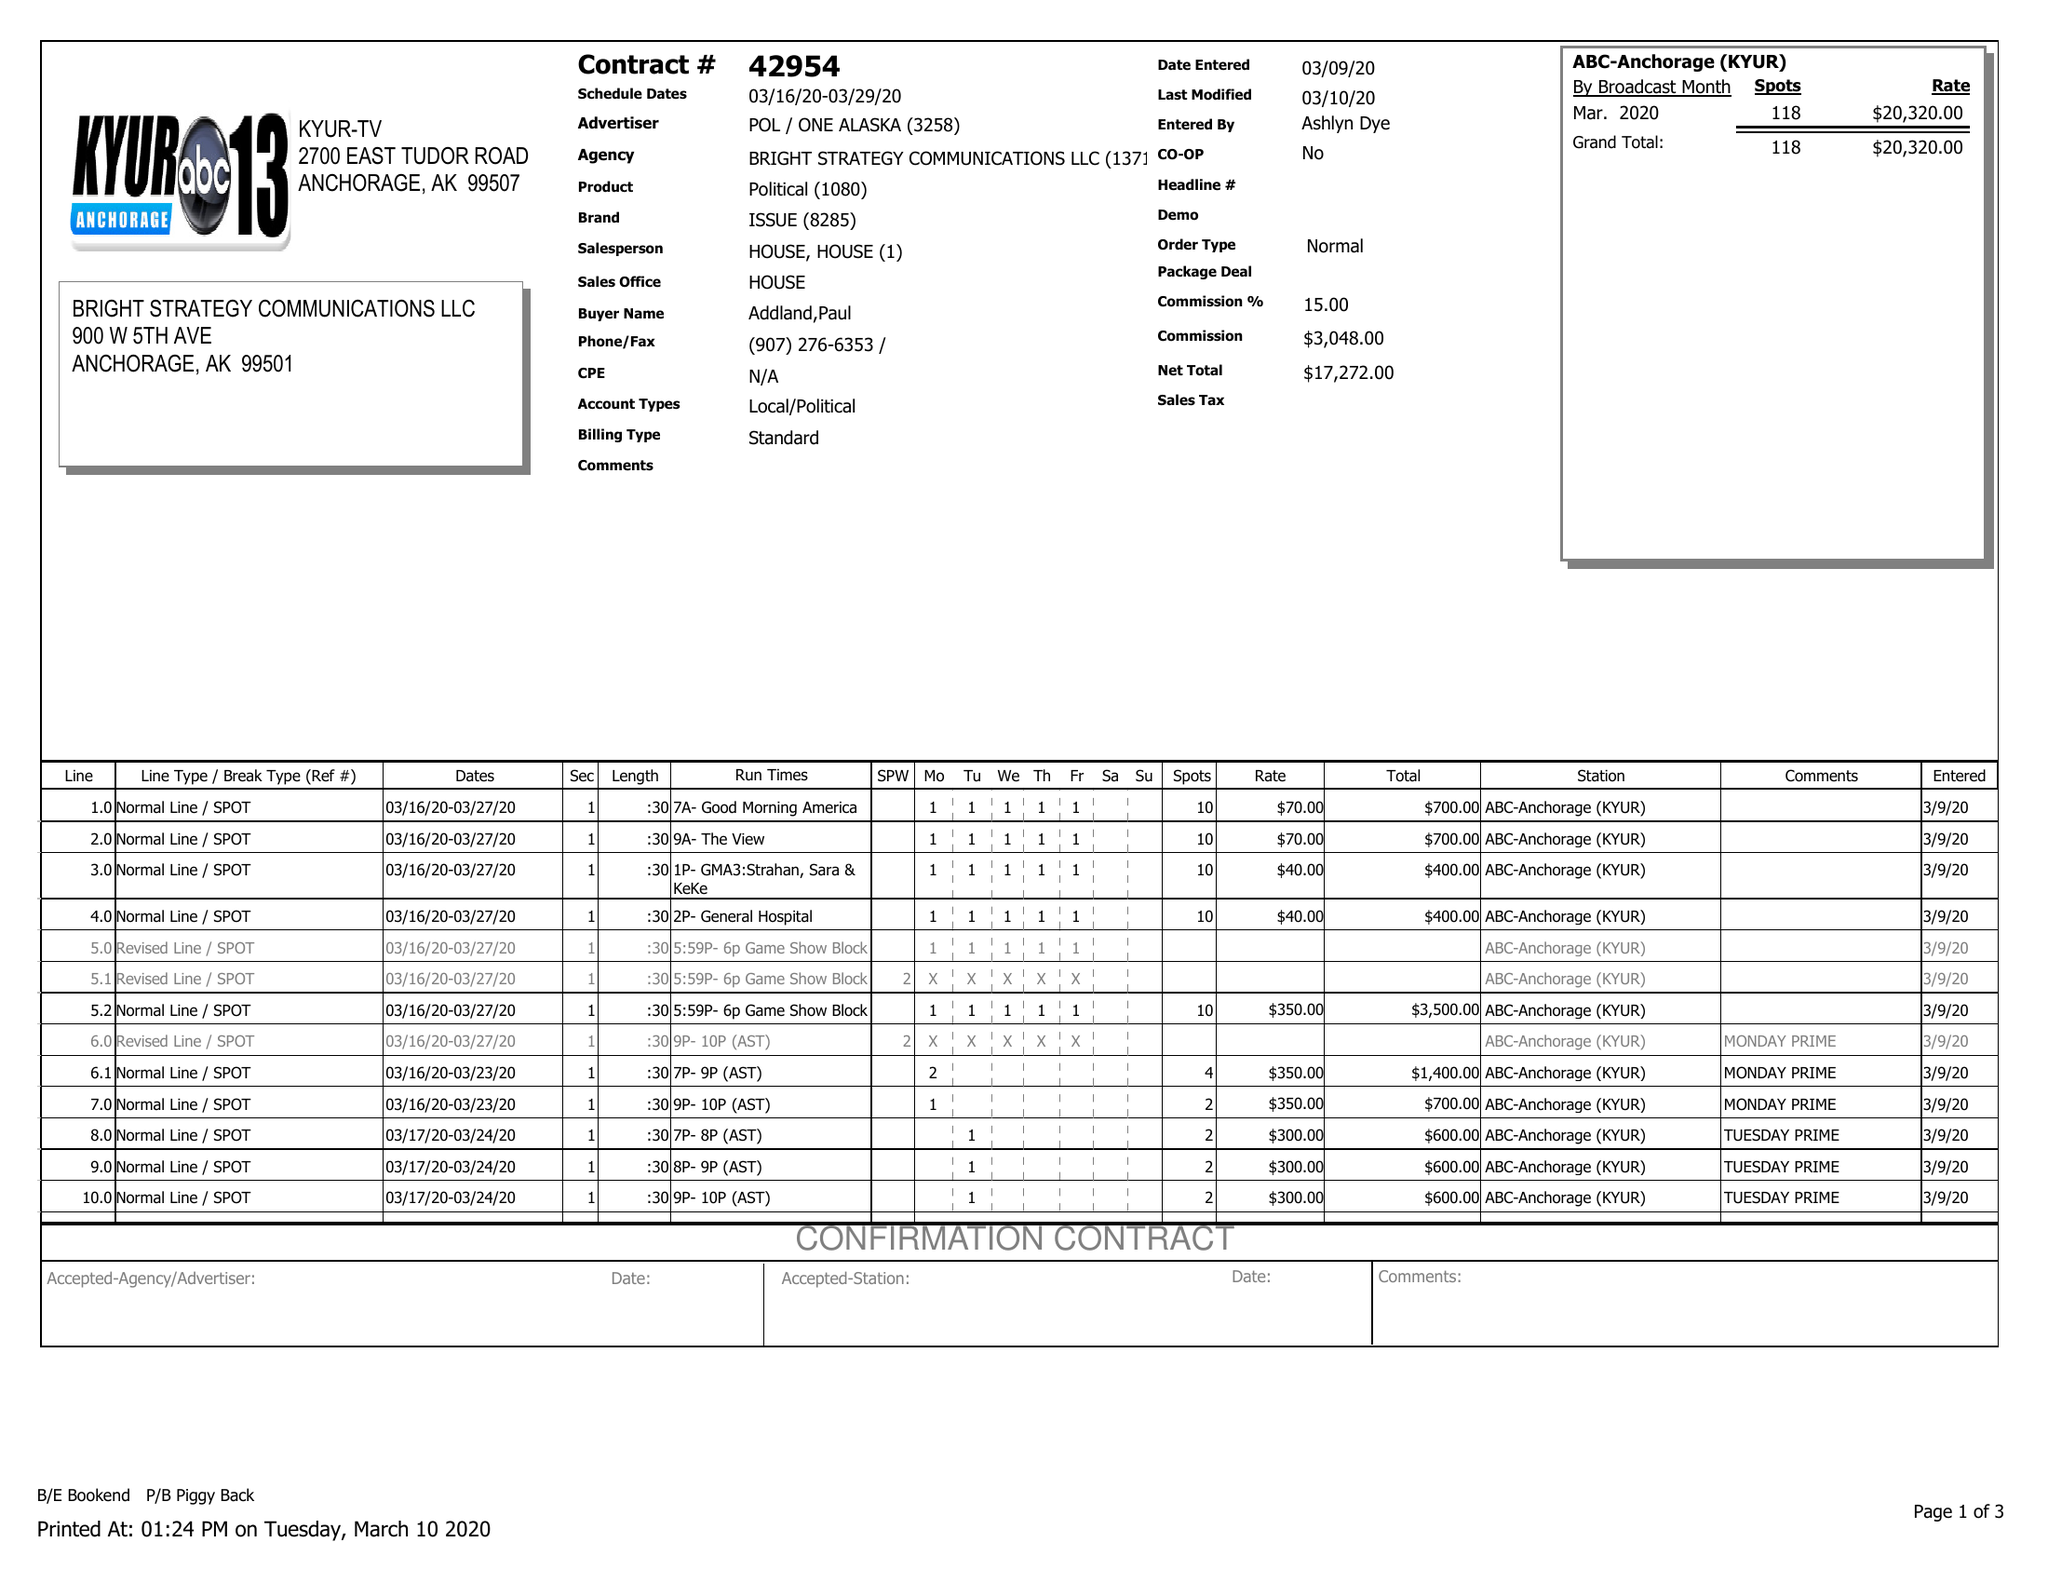What is the value for the advertiser?
Answer the question using a single word or phrase. POL/ONEALASKA 